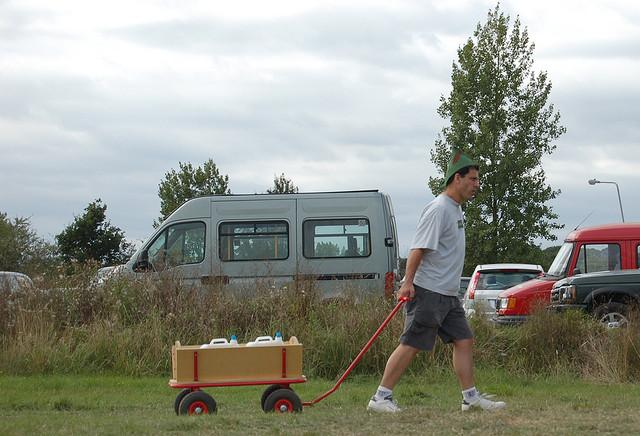What color is the main body of the cart pulled by this guy? brown 